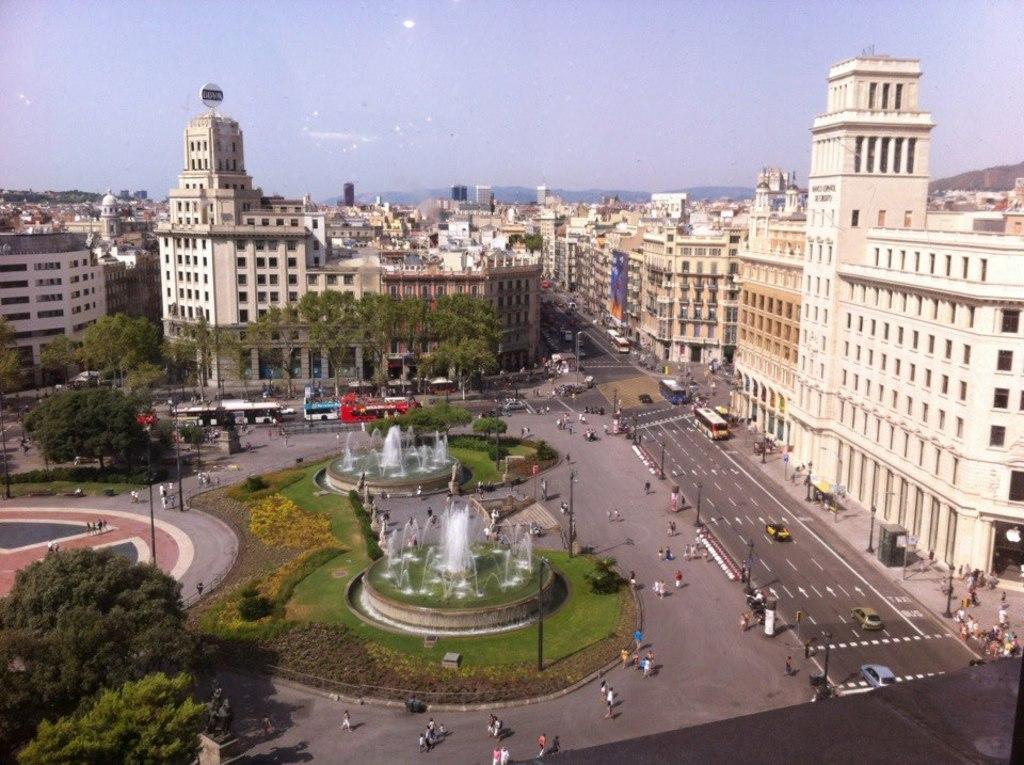Please provide a concise description of this image. This picture is clicked outside the city. In this picture, we see many people are walking on the road. We even see vehicles are moving on the road. On either side of the road, we see poles. In the middle of the picture, we see fountains, grass and shrubs. In the left bottom of the picture, we see trees. There are trees and buildings in the background. We even see the hills in the background. At the top of the picture, we see the sky. 